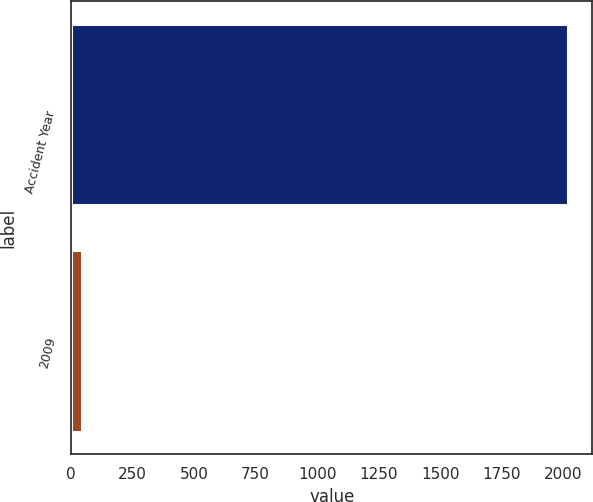<chart> <loc_0><loc_0><loc_500><loc_500><bar_chart><fcel>Accident Year<fcel>2009<nl><fcel>2017<fcel>44<nl></chart> 